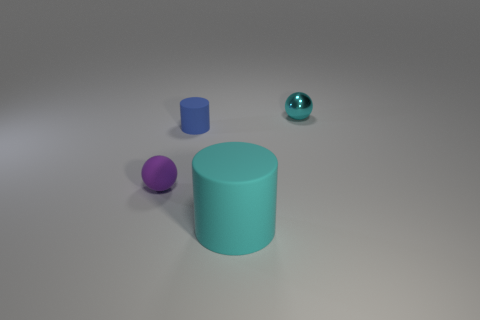Are there the same number of purple things that are to the left of the large matte cylinder and purple spheres?
Offer a terse response. Yes. Is there any other thing that is the same material as the cyan ball?
Your response must be concise. No. There is a large cylinder right of the blue thing; does it have the same color as the tiny sphere to the left of the small cylinder?
Provide a succinct answer. No. How many small spheres are both on the right side of the blue matte cylinder and in front of the metal sphere?
Keep it short and to the point. 0. What number of other objects are the same shape as the small cyan metal thing?
Make the answer very short. 1. Are there more cylinders left of the large matte cylinder than spheres?
Your response must be concise. No. There is a ball left of the big cyan rubber object; what is its color?
Make the answer very short. Purple. There is another metallic thing that is the same color as the large object; what is its size?
Your answer should be compact. Small. How many rubber things are either small blue cubes or spheres?
Make the answer very short. 1. There is a cyan thing that is to the left of the tiny sphere that is behind the small blue matte cylinder; are there any blue cylinders right of it?
Offer a terse response. No. 